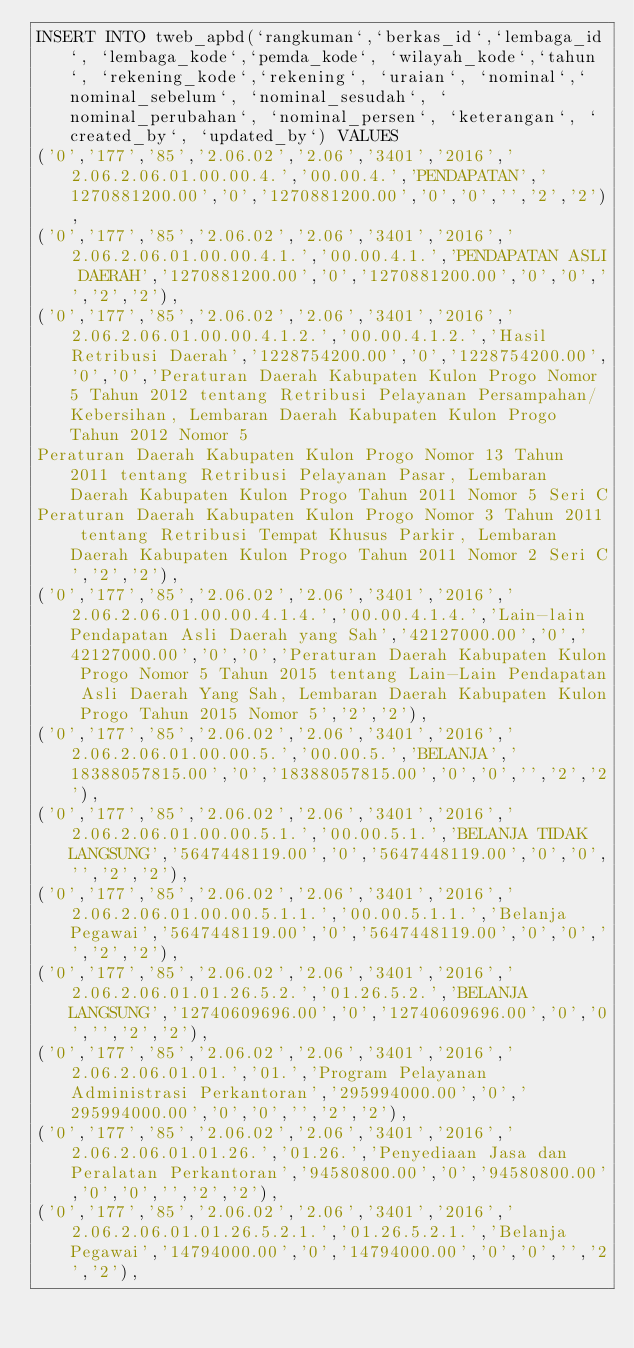<code> <loc_0><loc_0><loc_500><loc_500><_SQL_>INSERT INTO tweb_apbd(`rangkuman`,`berkas_id`,`lembaga_id`, `lembaga_kode`,`pemda_kode`, `wilayah_kode`,`tahun`, `rekening_kode`,`rekening`, `uraian`, `nominal`,`nominal_sebelum`, `nominal_sesudah`, `nominal_perubahan`, `nominal_persen`, `keterangan`, `created_by`, `updated_by`) VALUES 
('0','177','85','2.06.02','2.06','3401','2016','2.06.2.06.01.00.00.4.','00.00.4.','PENDAPATAN','1270881200.00','0','1270881200.00','0','0','','2','2'),
('0','177','85','2.06.02','2.06','3401','2016','2.06.2.06.01.00.00.4.1.','00.00.4.1.','PENDAPATAN ASLI DAERAH','1270881200.00','0','1270881200.00','0','0','','2','2'),
('0','177','85','2.06.02','2.06','3401','2016','2.06.2.06.01.00.00.4.1.2.','00.00.4.1.2.','Hasil Retribusi Daerah','1228754200.00','0','1228754200.00','0','0','Peraturan Daerah Kabupaten Kulon Progo Nomor 5 Tahun 2012 tentang Retribusi Pelayanan Persampahan/Kebersihan, Lembaran Daerah Kabupaten Kulon Progo Tahun 2012 Nomor 5
Peraturan Daerah Kabupaten Kulon Progo Nomor 13 Tahun 2011 tentang Retribusi Pelayanan Pasar, Lembaran Daerah Kabupaten Kulon Progo Tahun 2011 Nomor 5 Seri C
Peraturan Daerah Kabupaten Kulon Progo Nomor 3 Tahun 2011 tentang Retribusi Tempat Khusus Parkir, Lembaran Daerah Kabupaten Kulon Progo Tahun 2011 Nomor 2 Seri C','2','2'),
('0','177','85','2.06.02','2.06','3401','2016','2.06.2.06.01.00.00.4.1.4.','00.00.4.1.4.','Lain-lain Pendapatan Asli Daerah yang Sah','42127000.00','0','42127000.00','0','0','Peraturan Daerah Kabupaten Kulon Progo Nomor 5 Tahun 2015 tentang Lain-Lain Pendapatan Asli Daerah Yang Sah, Lembaran Daerah Kabupaten Kulon Progo Tahun 2015 Nomor 5','2','2'),
('0','177','85','2.06.02','2.06','3401','2016','2.06.2.06.01.00.00.5.','00.00.5.','BELANJA','18388057815.00','0','18388057815.00','0','0','','2','2'),
('0','177','85','2.06.02','2.06','3401','2016','2.06.2.06.01.00.00.5.1.','00.00.5.1.','BELANJA TIDAK LANGSUNG','5647448119.00','0','5647448119.00','0','0','','2','2'),
('0','177','85','2.06.02','2.06','3401','2016','2.06.2.06.01.00.00.5.1.1.','00.00.5.1.1.','Belanja Pegawai','5647448119.00','0','5647448119.00','0','0','','2','2'),
('0','177','85','2.06.02','2.06','3401','2016','2.06.2.06.01.01.26.5.2.','01.26.5.2.','BELANJA LANGSUNG','12740609696.00','0','12740609696.00','0','0','','2','2'),
('0','177','85','2.06.02','2.06','3401','2016','2.06.2.06.01.01.','01.','Program Pelayanan Administrasi Perkantoran','295994000.00','0','295994000.00','0','0','','2','2'),
('0','177','85','2.06.02','2.06','3401','2016','2.06.2.06.01.01.26.','01.26.','Penyediaan Jasa dan Peralatan Perkantoran','94580800.00','0','94580800.00','0','0','','2','2'),
('0','177','85','2.06.02','2.06','3401','2016','2.06.2.06.01.01.26.5.2.1.','01.26.5.2.1.','Belanja Pegawai','14794000.00','0','14794000.00','0','0','','2','2'),</code> 